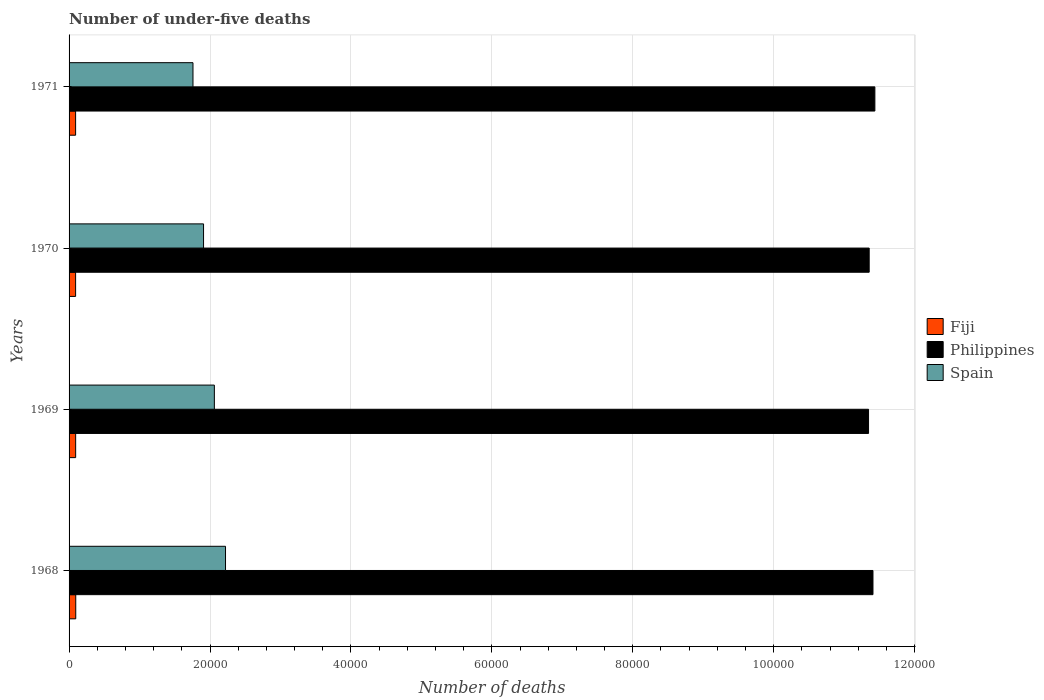How many groups of bars are there?
Make the answer very short. 4. Are the number of bars per tick equal to the number of legend labels?
Your response must be concise. Yes. How many bars are there on the 2nd tick from the top?
Provide a succinct answer. 3. How many bars are there on the 2nd tick from the bottom?
Your response must be concise. 3. What is the label of the 3rd group of bars from the top?
Your response must be concise. 1969. What is the number of under-five deaths in Spain in 1969?
Your answer should be very brief. 2.06e+04. Across all years, what is the maximum number of under-five deaths in Fiji?
Give a very brief answer. 949. Across all years, what is the minimum number of under-five deaths in Spain?
Your answer should be compact. 1.76e+04. In which year was the number of under-five deaths in Spain maximum?
Give a very brief answer. 1968. In which year was the number of under-five deaths in Philippines minimum?
Your response must be concise. 1969. What is the total number of under-five deaths in Spain in the graph?
Ensure brevity in your answer.  7.95e+04. What is the difference between the number of under-five deaths in Spain in 1970 and that in 1971?
Your answer should be compact. 1500. What is the difference between the number of under-five deaths in Spain in 1971 and the number of under-five deaths in Fiji in 1969?
Provide a succinct answer. 1.67e+04. What is the average number of under-five deaths in Spain per year?
Your response must be concise. 1.99e+04. In the year 1969, what is the difference between the number of under-five deaths in Spain and number of under-five deaths in Philippines?
Keep it short and to the point. -9.28e+04. What is the ratio of the number of under-five deaths in Fiji in 1969 to that in 1970?
Ensure brevity in your answer.  1.01. Is the difference between the number of under-five deaths in Spain in 1969 and 1971 greater than the difference between the number of under-five deaths in Philippines in 1969 and 1971?
Offer a terse response. Yes. What is the difference between the highest and the second highest number of under-five deaths in Philippines?
Your answer should be compact. 270. What is the difference between the highest and the lowest number of under-five deaths in Spain?
Your answer should be very brief. 4617. In how many years, is the number of under-five deaths in Spain greater than the average number of under-five deaths in Spain taken over all years?
Provide a short and direct response. 2. Is the sum of the number of under-five deaths in Fiji in 1968 and 1969 greater than the maximum number of under-five deaths in Philippines across all years?
Your answer should be compact. No. What does the 3rd bar from the top in 1969 represents?
Your answer should be very brief. Fiji. What does the 3rd bar from the bottom in 1970 represents?
Your response must be concise. Spain. Is it the case that in every year, the sum of the number of under-five deaths in Spain and number of under-five deaths in Philippines is greater than the number of under-five deaths in Fiji?
Offer a very short reply. Yes. How many bars are there?
Ensure brevity in your answer.  12. How many years are there in the graph?
Give a very brief answer. 4. Does the graph contain grids?
Offer a very short reply. Yes. How are the legend labels stacked?
Provide a short and direct response. Vertical. What is the title of the graph?
Make the answer very short. Number of under-five deaths. What is the label or title of the X-axis?
Offer a very short reply. Number of deaths. What is the Number of deaths in Fiji in 1968?
Provide a succinct answer. 949. What is the Number of deaths in Philippines in 1968?
Make the answer very short. 1.14e+05. What is the Number of deaths of Spain in 1968?
Keep it short and to the point. 2.22e+04. What is the Number of deaths in Fiji in 1969?
Your answer should be very brief. 934. What is the Number of deaths of Philippines in 1969?
Provide a succinct answer. 1.13e+05. What is the Number of deaths in Spain in 1969?
Provide a succinct answer. 2.06e+04. What is the Number of deaths in Fiji in 1970?
Offer a terse response. 927. What is the Number of deaths of Philippines in 1970?
Give a very brief answer. 1.14e+05. What is the Number of deaths of Spain in 1970?
Your response must be concise. 1.91e+04. What is the Number of deaths of Fiji in 1971?
Give a very brief answer. 927. What is the Number of deaths in Philippines in 1971?
Your response must be concise. 1.14e+05. What is the Number of deaths in Spain in 1971?
Provide a short and direct response. 1.76e+04. Across all years, what is the maximum Number of deaths of Fiji?
Keep it short and to the point. 949. Across all years, what is the maximum Number of deaths of Philippines?
Your answer should be very brief. 1.14e+05. Across all years, what is the maximum Number of deaths of Spain?
Your answer should be very brief. 2.22e+04. Across all years, what is the minimum Number of deaths of Fiji?
Make the answer very short. 927. Across all years, what is the minimum Number of deaths in Philippines?
Offer a very short reply. 1.13e+05. Across all years, what is the minimum Number of deaths in Spain?
Ensure brevity in your answer.  1.76e+04. What is the total Number of deaths in Fiji in the graph?
Your answer should be compact. 3737. What is the total Number of deaths of Philippines in the graph?
Your answer should be compact. 4.55e+05. What is the total Number of deaths in Spain in the graph?
Your answer should be compact. 7.95e+04. What is the difference between the Number of deaths in Fiji in 1968 and that in 1969?
Make the answer very short. 15. What is the difference between the Number of deaths of Philippines in 1968 and that in 1969?
Your response must be concise. 627. What is the difference between the Number of deaths of Spain in 1968 and that in 1969?
Offer a terse response. 1584. What is the difference between the Number of deaths of Fiji in 1968 and that in 1970?
Provide a short and direct response. 22. What is the difference between the Number of deaths of Philippines in 1968 and that in 1970?
Ensure brevity in your answer.  536. What is the difference between the Number of deaths in Spain in 1968 and that in 1970?
Your response must be concise. 3117. What is the difference between the Number of deaths of Fiji in 1968 and that in 1971?
Keep it short and to the point. 22. What is the difference between the Number of deaths of Philippines in 1968 and that in 1971?
Provide a short and direct response. -270. What is the difference between the Number of deaths of Spain in 1968 and that in 1971?
Offer a terse response. 4617. What is the difference between the Number of deaths of Fiji in 1969 and that in 1970?
Provide a short and direct response. 7. What is the difference between the Number of deaths in Philippines in 1969 and that in 1970?
Your answer should be compact. -91. What is the difference between the Number of deaths of Spain in 1969 and that in 1970?
Give a very brief answer. 1533. What is the difference between the Number of deaths of Fiji in 1969 and that in 1971?
Offer a very short reply. 7. What is the difference between the Number of deaths in Philippines in 1969 and that in 1971?
Offer a terse response. -897. What is the difference between the Number of deaths of Spain in 1969 and that in 1971?
Give a very brief answer. 3033. What is the difference between the Number of deaths of Philippines in 1970 and that in 1971?
Offer a very short reply. -806. What is the difference between the Number of deaths of Spain in 1970 and that in 1971?
Ensure brevity in your answer.  1500. What is the difference between the Number of deaths of Fiji in 1968 and the Number of deaths of Philippines in 1969?
Your response must be concise. -1.13e+05. What is the difference between the Number of deaths of Fiji in 1968 and the Number of deaths of Spain in 1969?
Your response must be concise. -1.97e+04. What is the difference between the Number of deaths in Philippines in 1968 and the Number of deaths in Spain in 1969?
Your response must be concise. 9.35e+04. What is the difference between the Number of deaths of Fiji in 1968 and the Number of deaths of Philippines in 1970?
Make the answer very short. -1.13e+05. What is the difference between the Number of deaths in Fiji in 1968 and the Number of deaths in Spain in 1970?
Offer a terse response. -1.81e+04. What is the difference between the Number of deaths in Philippines in 1968 and the Number of deaths in Spain in 1970?
Your answer should be compact. 9.50e+04. What is the difference between the Number of deaths of Fiji in 1968 and the Number of deaths of Philippines in 1971?
Provide a short and direct response. -1.13e+05. What is the difference between the Number of deaths in Fiji in 1968 and the Number of deaths in Spain in 1971?
Your response must be concise. -1.66e+04. What is the difference between the Number of deaths in Philippines in 1968 and the Number of deaths in Spain in 1971?
Ensure brevity in your answer.  9.65e+04. What is the difference between the Number of deaths of Fiji in 1969 and the Number of deaths of Philippines in 1970?
Ensure brevity in your answer.  -1.13e+05. What is the difference between the Number of deaths of Fiji in 1969 and the Number of deaths of Spain in 1970?
Provide a succinct answer. -1.82e+04. What is the difference between the Number of deaths of Philippines in 1969 and the Number of deaths of Spain in 1970?
Offer a terse response. 9.44e+04. What is the difference between the Number of deaths of Fiji in 1969 and the Number of deaths of Philippines in 1971?
Keep it short and to the point. -1.13e+05. What is the difference between the Number of deaths of Fiji in 1969 and the Number of deaths of Spain in 1971?
Offer a terse response. -1.67e+04. What is the difference between the Number of deaths of Philippines in 1969 and the Number of deaths of Spain in 1971?
Provide a succinct answer. 9.59e+04. What is the difference between the Number of deaths in Fiji in 1970 and the Number of deaths in Philippines in 1971?
Offer a terse response. -1.13e+05. What is the difference between the Number of deaths of Fiji in 1970 and the Number of deaths of Spain in 1971?
Your answer should be compact. -1.67e+04. What is the difference between the Number of deaths in Philippines in 1970 and the Number of deaths in Spain in 1971?
Give a very brief answer. 9.60e+04. What is the average Number of deaths of Fiji per year?
Provide a succinct answer. 934.25. What is the average Number of deaths in Philippines per year?
Provide a succinct answer. 1.14e+05. What is the average Number of deaths of Spain per year?
Provide a succinct answer. 1.99e+04. In the year 1968, what is the difference between the Number of deaths of Fiji and Number of deaths of Philippines?
Your answer should be compact. -1.13e+05. In the year 1968, what is the difference between the Number of deaths in Fiji and Number of deaths in Spain?
Offer a very short reply. -2.13e+04. In the year 1968, what is the difference between the Number of deaths of Philippines and Number of deaths of Spain?
Ensure brevity in your answer.  9.19e+04. In the year 1969, what is the difference between the Number of deaths of Fiji and Number of deaths of Philippines?
Provide a succinct answer. -1.13e+05. In the year 1969, what is the difference between the Number of deaths in Fiji and Number of deaths in Spain?
Offer a very short reply. -1.97e+04. In the year 1969, what is the difference between the Number of deaths in Philippines and Number of deaths in Spain?
Your response must be concise. 9.28e+04. In the year 1970, what is the difference between the Number of deaths in Fiji and Number of deaths in Philippines?
Make the answer very short. -1.13e+05. In the year 1970, what is the difference between the Number of deaths in Fiji and Number of deaths in Spain?
Ensure brevity in your answer.  -1.82e+04. In the year 1970, what is the difference between the Number of deaths of Philippines and Number of deaths of Spain?
Make the answer very short. 9.45e+04. In the year 1971, what is the difference between the Number of deaths of Fiji and Number of deaths of Philippines?
Provide a succinct answer. -1.13e+05. In the year 1971, what is the difference between the Number of deaths in Fiji and Number of deaths in Spain?
Give a very brief answer. -1.67e+04. In the year 1971, what is the difference between the Number of deaths in Philippines and Number of deaths in Spain?
Ensure brevity in your answer.  9.68e+04. What is the ratio of the Number of deaths in Fiji in 1968 to that in 1969?
Provide a succinct answer. 1.02. What is the ratio of the Number of deaths in Philippines in 1968 to that in 1969?
Ensure brevity in your answer.  1.01. What is the ratio of the Number of deaths in Spain in 1968 to that in 1969?
Offer a very short reply. 1.08. What is the ratio of the Number of deaths of Fiji in 1968 to that in 1970?
Provide a short and direct response. 1.02. What is the ratio of the Number of deaths of Philippines in 1968 to that in 1970?
Offer a terse response. 1. What is the ratio of the Number of deaths in Spain in 1968 to that in 1970?
Ensure brevity in your answer.  1.16. What is the ratio of the Number of deaths of Fiji in 1968 to that in 1971?
Provide a short and direct response. 1.02. What is the ratio of the Number of deaths in Philippines in 1968 to that in 1971?
Your answer should be very brief. 1. What is the ratio of the Number of deaths in Spain in 1968 to that in 1971?
Provide a short and direct response. 1.26. What is the ratio of the Number of deaths of Fiji in 1969 to that in 1970?
Provide a succinct answer. 1.01. What is the ratio of the Number of deaths in Philippines in 1969 to that in 1970?
Offer a very short reply. 1. What is the ratio of the Number of deaths in Spain in 1969 to that in 1970?
Offer a terse response. 1.08. What is the ratio of the Number of deaths in Fiji in 1969 to that in 1971?
Your response must be concise. 1.01. What is the ratio of the Number of deaths in Spain in 1969 to that in 1971?
Your response must be concise. 1.17. What is the ratio of the Number of deaths of Fiji in 1970 to that in 1971?
Provide a succinct answer. 1. What is the ratio of the Number of deaths in Philippines in 1970 to that in 1971?
Offer a very short reply. 0.99. What is the ratio of the Number of deaths of Spain in 1970 to that in 1971?
Provide a short and direct response. 1.09. What is the difference between the highest and the second highest Number of deaths in Philippines?
Offer a very short reply. 270. What is the difference between the highest and the second highest Number of deaths in Spain?
Give a very brief answer. 1584. What is the difference between the highest and the lowest Number of deaths of Philippines?
Ensure brevity in your answer.  897. What is the difference between the highest and the lowest Number of deaths in Spain?
Your answer should be very brief. 4617. 